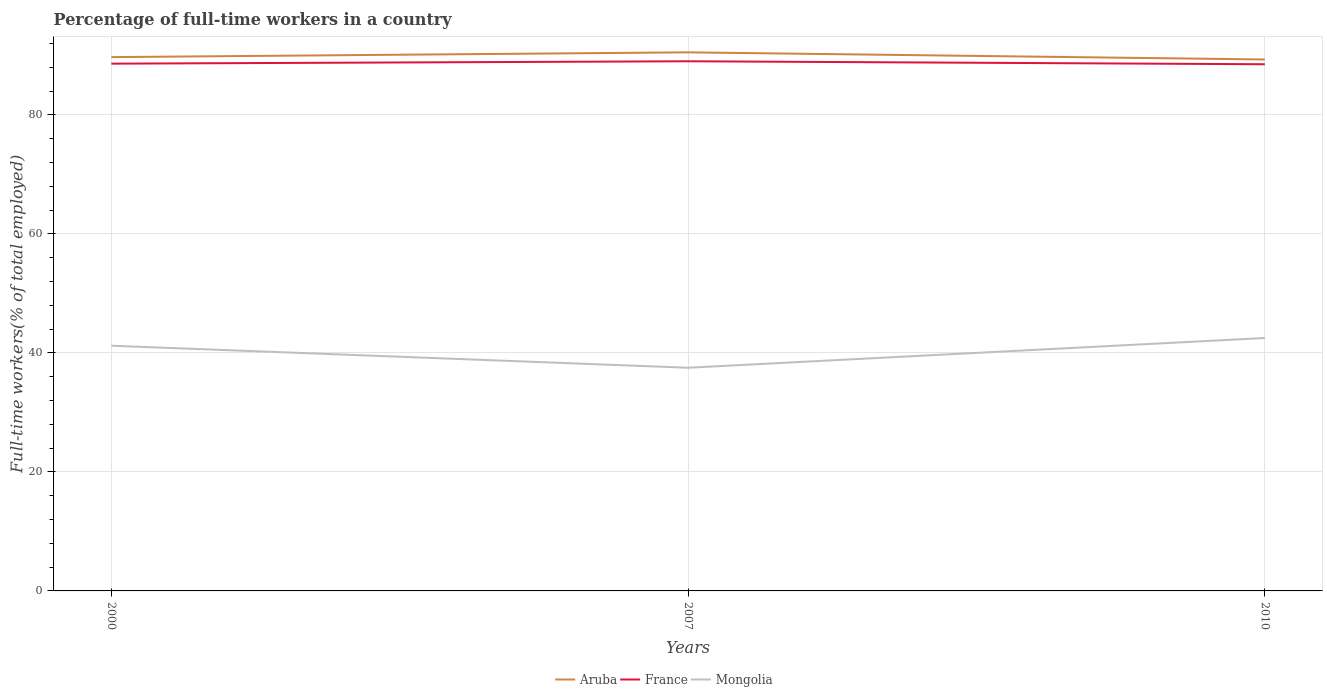How many different coloured lines are there?
Give a very brief answer. 3. Across all years, what is the maximum percentage of full-time workers in France?
Offer a very short reply. 88.5. In which year was the percentage of full-time workers in Mongolia maximum?
Keep it short and to the point. 2007. What is the total percentage of full-time workers in Aruba in the graph?
Ensure brevity in your answer.  0.4. What is the difference between the highest and the second highest percentage of full-time workers in Mongolia?
Keep it short and to the point. 5. Is the percentage of full-time workers in Mongolia strictly greater than the percentage of full-time workers in France over the years?
Give a very brief answer. Yes. How many lines are there?
Make the answer very short. 3. Are the values on the major ticks of Y-axis written in scientific E-notation?
Provide a succinct answer. No. Does the graph contain any zero values?
Ensure brevity in your answer.  No. Where does the legend appear in the graph?
Offer a terse response. Bottom center. How many legend labels are there?
Provide a short and direct response. 3. What is the title of the graph?
Your answer should be compact. Percentage of full-time workers in a country. What is the label or title of the Y-axis?
Give a very brief answer. Full-time workers(% of total employed). What is the Full-time workers(% of total employed) of Aruba in 2000?
Keep it short and to the point. 89.7. What is the Full-time workers(% of total employed) of France in 2000?
Give a very brief answer. 88.6. What is the Full-time workers(% of total employed) in Mongolia in 2000?
Ensure brevity in your answer.  41.2. What is the Full-time workers(% of total employed) of Aruba in 2007?
Provide a short and direct response. 90.5. What is the Full-time workers(% of total employed) of France in 2007?
Provide a succinct answer. 89. What is the Full-time workers(% of total employed) of Mongolia in 2007?
Offer a very short reply. 37.5. What is the Full-time workers(% of total employed) in Aruba in 2010?
Provide a succinct answer. 89.3. What is the Full-time workers(% of total employed) in France in 2010?
Give a very brief answer. 88.5. What is the Full-time workers(% of total employed) in Mongolia in 2010?
Provide a short and direct response. 42.5. Across all years, what is the maximum Full-time workers(% of total employed) of Aruba?
Keep it short and to the point. 90.5. Across all years, what is the maximum Full-time workers(% of total employed) in France?
Your response must be concise. 89. Across all years, what is the maximum Full-time workers(% of total employed) of Mongolia?
Your answer should be compact. 42.5. Across all years, what is the minimum Full-time workers(% of total employed) of Aruba?
Your answer should be compact. 89.3. Across all years, what is the minimum Full-time workers(% of total employed) in France?
Your answer should be compact. 88.5. Across all years, what is the minimum Full-time workers(% of total employed) of Mongolia?
Make the answer very short. 37.5. What is the total Full-time workers(% of total employed) of Aruba in the graph?
Give a very brief answer. 269.5. What is the total Full-time workers(% of total employed) of France in the graph?
Provide a succinct answer. 266.1. What is the total Full-time workers(% of total employed) in Mongolia in the graph?
Keep it short and to the point. 121.2. What is the difference between the Full-time workers(% of total employed) in Aruba in 2000 and that in 2007?
Your answer should be compact. -0.8. What is the difference between the Full-time workers(% of total employed) of France in 2000 and that in 2007?
Offer a terse response. -0.4. What is the difference between the Full-time workers(% of total employed) of Mongolia in 2000 and that in 2007?
Provide a succinct answer. 3.7. What is the difference between the Full-time workers(% of total employed) in Aruba in 2000 and that in 2010?
Provide a short and direct response. 0.4. What is the difference between the Full-time workers(% of total employed) of Mongolia in 2000 and that in 2010?
Make the answer very short. -1.3. What is the difference between the Full-time workers(% of total employed) in Aruba in 2000 and the Full-time workers(% of total employed) in France in 2007?
Make the answer very short. 0.7. What is the difference between the Full-time workers(% of total employed) of Aruba in 2000 and the Full-time workers(% of total employed) of Mongolia in 2007?
Provide a succinct answer. 52.2. What is the difference between the Full-time workers(% of total employed) of France in 2000 and the Full-time workers(% of total employed) of Mongolia in 2007?
Your response must be concise. 51.1. What is the difference between the Full-time workers(% of total employed) of Aruba in 2000 and the Full-time workers(% of total employed) of France in 2010?
Your answer should be compact. 1.2. What is the difference between the Full-time workers(% of total employed) in Aruba in 2000 and the Full-time workers(% of total employed) in Mongolia in 2010?
Keep it short and to the point. 47.2. What is the difference between the Full-time workers(% of total employed) of France in 2000 and the Full-time workers(% of total employed) of Mongolia in 2010?
Offer a terse response. 46.1. What is the difference between the Full-time workers(% of total employed) in Aruba in 2007 and the Full-time workers(% of total employed) in France in 2010?
Make the answer very short. 2. What is the difference between the Full-time workers(% of total employed) in Aruba in 2007 and the Full-time workers(% of total employed) in Mongolia in 2010?
Give a very brief answer. 48. What is the difference between the Full-time workers(% of total employed) of France in 2007 and the Full-time workers(% of total employed) of Mongolia in 2010?
Provide a short and direct response. 46.5. What is the average Full-time workers(% of total employed) in Aruba per year?
Make the answer very short. 89.83. What is the average Full-time workers(% of total employed) in France per year?
Ensure brevity in your answer.  88.7. What is the average Full-time workers(% of total employed) in Mongolia per year?
Your answer should be very brief. 40.4. In the year 2000, what is the difference between the Full-time workers(% of total employed) of Aruba and Full-time workers(% of total employed) of France?
Provide a succinct answer. 1.1. In the year 2000, what is the difference between the Full-time workers(% of total employed) of Aruba and Full-time workers(% of total employed) of Mongolia?
Your answer should be very brief. 48.5. In the year 2000, what is the difference between the Full-time workers(% of total employed) of France and Full-time workers(% of total employed) of Mongolia?
Keep it short and to the point. 47.4. In the year 2007, what is the difference between the Full-time workers(% of total employed) of Aruba and Full-time workers(% of total employed) of France?
Offer a terse response. 1.5. In the year 2007, what is the difference between the Full-time workers(% of total employed) in Aruba and Full-time workers(% of total employed) in Mongolia?
Give a very brief answer. 53. In the year 2007, what is the difference between the Full-time workers(% of total employed) in France and Full-time workers(% of total employed) in Mongolia?
Keep it short and to the point. 51.5. In the year 2010, what is the difference between the Full-time workers(% of total employed) of Aruba and Full-time workers(% of total employed) of France?
Provide a succinct answer. 0.8. In the year 2010, what is the difference between the Full-time workers(% of total employed) of Aruba and Full-time workers(% of total employed) of Mongolia?
Offer a very short reply. 46.8. What is the ratio of the Full-time workers(% of total employed) in Aruba in 2000 to that in 2007?
Offer a terse response. 0.99. What is the ratio of the Full-time workers(% of total employed) in Mongolia in 2000 to that in 2007?
Keep it short and to the point. 1.1. What is the ratio of the Full-time workers(% of total employed) in Mongolia in 2000 to that in 2010?
Your response must be concise. 0.97. What is the ratio of the Full-time workers(% of total employed) in Aruba in 2007 to that in 2010?
Offer a terse response. 1.01. What is the ratio of the Full-time workers(% of total employed) of France in 2007 to that in 2010?
Your answer should be compact. 1.01. What is the ratio of the Full-time workers(% of total employed) of Mongolia in 2007 to that in 2010?
Ensure brevity in your answer.  0.88. What is the difference between the highest and the second highest Full-time workers(% of total employed) in Aruba?
Provide a succinct answer. 0.8. What is the difference between the highest and the second highest Full-time workers(% of total employed) in France?
Provide a short and direct response. 0.4. What is the difference between the highest and the second highest Full-time workers(% of total employed) of Mongolia?
Offer a terse response. 1.3. What is the difference between the highest and the lowest Full-time workers(% of total employed) in Mongolia?
Keep it short and to the point. 5. 